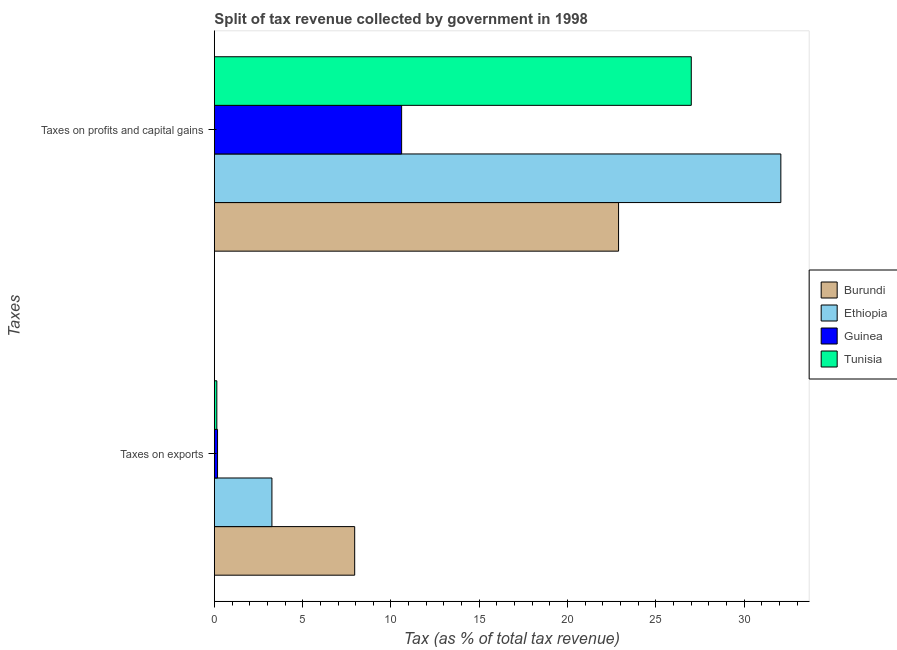How many different coloured bars are there?
Keep it short and to the point. 4. How many groups of bars are there?
Offer a very short reply. 2. Are the number of bars per tick equal to the number of legend labels?
Give a very brief answer. Yes. Are the number of bars on each tick of the Y-axis equal?
Make the answer very short. Yes. How many bars are there on the 2nd tick from the bottom?
Keep it short and to the point. 4. What is the label of the 1st group of bars from the top?
Provide a succinct answer. Taxes on profits and capital gains. What is the percentage of revenue obtained from taxes on exports in Guinea?
Provide a succinct answer. 0.18. Across all countries, what is the maximum percentage of revenue obtained from taxes on exports?
Make the answer very short. 7.94. Across all countries, what is the minimum percentage of revenue obtained from taxes on exports?
Keep it short and to the point. 0.14. In which country was the percentage of revenue obtained from taxes on profits and capital gains maximum?
Offer a terse response. Ethiopia. In which country was the percentage of revenue obtained from taxes on profits and capital gains minimum?
Ensure brevity in your answer.  Guinea. What is the total percentage of revenue obtained from taxes on profits and capital gains in the graph?
Offer a terse response. 92.55. What is the difference between the percentage of revenue obtained from taxes on profits and capital gains in Burundi and that in Ethiopia?
Give a very brief answer. -9.19. What is the difference between the percentage of revenue obtained from taxes on profits and capital gains in Ethiopia and the percentage of revenue obtained from taxes on exports in Guinea?
Your response must be concise. 31.89. What is the average percentage of revenue obtained from taxes on profits and capital gains per country?
Your answer should be compact. 23.14. What is the difference between the percentage of revenue obtained from taxes on profits and capital gains and percentage of revenue obtained from taxes on exports in Ethiopia?
Provide a short and direct response. 28.81. In how many countries, is the percentage of revenue obtained from taxes on profits and capital gains greater than 14 %?
Provide a succinct answer. 3. What is the ratio of the percentage of revenue obtained from taxes on exports in Ethiopia to that in Tunisia?
Offer a very short reply. 23.17. In how many countries, is the percentage of revenue obtained from taxes on profits and capital gains greater than the average percentage of revenue obtained from taxes on profits and capital gains taken over all countries?
Ensure brevity in your answer.  2. What does the 3rd bar from the top in Taxes on profits and capital gains represents?
Provide a succinct answer. Ethiopia. What does the 3rd bar from the bottom in Taxes on exports represents?
Your answer should be compact. Guinea. How many countries are there in the graph?
Your answer should be very brief. 4. Are the values on the major ticks of X-axis written in scientific E-notation?
Keep it short and to the point. No. Does the graph contain grids?
Your answer should be compact. No. How many legend labels are there?
Provide a succinct answer. 4. What is the title of the graph?
Keep it short and to the point. Split of tax revenue collected by government in 1998. What is the label or title of the X-axis?
Provide a succinct answer. Tax (as % of total tax revenue). What is the label or title of the Y-axis?
Provide a succinct answer. Taxes. What is the Tax (as % of total tax revenue) of Burundi in Taxes on exports?
Ensure brevity in your answer.  7.94. What is the Tax (as % of total tax revenue) of Ethiopia in Taxes on exports?
Ensure brevity in your answer.  3.26. What is the Tax (as % of total tax revenue) of Guinea in Taxes on exports?
Your answer should be very brief. 0.18. What is the Tax (as % of total tax revenue) in Tunisia in Taxes on exports?
Offer a very short reply. 0.14. What is the Tax (as % of total tax revenue) in Burundi in Taxes on profits and capital gains?
Keep it short and to the point. 22.88. What is the Tax (as % of total tax revenue) in Ethiopia in Taxes on profits and capital gains?
Provide a succinct answer. 32.07. What is the Tax (as % of total tax revenue) in Guinea in Taxes on profits and capital gains?
Keep it short and to the point. 10.6. What is the Tax (as % of total tax revenue) of Tunisia in Taxes on profits and capital gains?
Offer a terse response. 27. Across all Taxes, what is the maximum Tax (as % of total tax revenue) of Burundi?
Provide a succinct answer. 22.88. Across all Taxes, what is the maximum Tax (as % of total tax revenue) in Ethiopia?
Your response must be concise. 32.07. Across all Taxes, what is the maximum Tax (as % of total tax revenue) of Guinea?
Offer a terse response. 10.6. Across all Taxes, what is the maximum Tax (as % of total tax revenue) of Tunisia?
Give a very brief answer. 27. Across all Taxes, what is the minimum Tax (as % of total tax revenue) in Burundi?
Ensure brevity in your answer.  7.94. Across all Taxes, what is the minimum Tax (as % of total tax revenue) in Ethiopia?
Make the answer very short. 3.26. Across all Taxes, what is the minimum Tax (as % of total tax revenue) of Guinea?
Your response must be concise. 0.18. Across all Taxes, what is the minimum Tax (as % of total tax revenue) of Tunisia?
Ensure brevity in your answer.  0.14. What is the total Tax (as % of total tax revenue) in Burundi in the graph?
Give a very brief answer. 30.83. What is the total Tax (as % of total tax revenue) of Ethiopia in the graph?
Your answer should be very brief. 35.33. What is the total Tax (as % of total tax revenue) in Guinea in the graph?
Your answer should be compact. 10.78. What is the total Tax (as % of total tax revenue) in Tunisia in the graph?
Keep it short and to the point. 27.14. What is the difference between the Tax (as % of total tax revenue) of Burundi in Taxes on exports and that in Taxes on profits and capital gains?
Provide a succinct answer. -14.94. What is the difference between the Tax (as % of total tax revenue) in Ethiopia in Taxes on exports and that in Taxes on profits and capital gains?
Your answer should be compact. -28.81. What is the difference between the Tax (as % of total tax revenue) in Guinea in Taxes on exports and that in Taxes on profits and capital gains?
Offer a terse response. -10.42. What is the difference between the Tax (as % of total tax revenue) of Tunisia in Taxes on exports and that in Taxes on profits and capital gains?
Offer a terse response. -26.86. What is the difference between the Tax (as % of total tax revenue) of Burundi in Taxes on exports and the Tax (as % of total tax revenue) of Ethiopia in Taxes on profits and capital gains?
Keep it short and to the point. -24.12. What is the difference between the Tax (as % of total tax revenue) of Burundi in Taxes on exports and the Tax (as % of total tax revenue) of Guinea in Taxes on profits and capital gains?
Provide a short and direct response. -2.66. What is the difference between the Tax (as % of total tax revenue) in Burundi in Taxes on exports and the Tax (as % of total tax revenue) in Tunisia in Taxes on profits and capital gains?
Make the answer very short. -19.05. What is the difference between the Tax (as % of total tax revenue) of Ethiopia in Taxes on exports and the Tax (as % of total tax revenue) of Guinea in Taxes on profits and capital gains?
Your response must be concise. -7.34. What is the difference between the Tax (as % of total tax revenue) of Ethiopia in Taxes on exports and the Tax (as % of total tax revenue) of Tunisia in Taxes on profits and capital gains?
Give a very brief answer. -23.74. What is the difference between the Tax (as % of total tax revenue) in Guinea in Taxes on exports and the Tax (as % of total tax revenue) in Tunisia in Taxes on profits and capital gains?
Ensure brevity in your answer.  -26.82. What is the average Tax (as % of total tax revenue) in Burundi per Taxes?
Ensure brevity in your answer.  15.41. What is the average Tax (as % of total tax revenue) in Ethiopia per Taxes?
Make the answer very short. 17.66. What is the average Tax (as % of total tax revenue) of Guinea per Taxes?
Make the answer very short. 5.39. What is the average Tax (as % of total tax revenue) in Tunisia per Taxes?
Keep it short and to the point. 13.57. What is the difference between the Tax (as % of total tax revenue) in Burundi and Tax (as % of total tax revenue) in Ethiopia in Taxes on exports?
Offer a very short reply. 4.69. What is the difference between the Tax (as % of total tax revenue) in Burundi and Tax (as % of total tax revenue) in Guinea in Taxes on exports?
Keep it short and to the point. 7.76. What is the difference between the Tax (as % of total tax revenue) in Burundi and Tax (as % of total tax revenue) in Tunisia in Taxes on exports?
Offer a terse response. 7.8. What is the difference between the Tax (as % of total tax revenue) of Ethiopia and Tax (as % of total tax revenue) of Guinea in Taxes on exports?
Give a very brief answer. 3.08. What is the difference between the Tax (as % of total tax revenue) in Ethiopia and Tax (as % of total tax revenue) in Tunisia in Taxes on exports?
Make the answer very short. 3.12. What is the difference between the Tax (as % of total tax revenue) of Guinea and Tax (as % of total tax revenue) of Tunisia in Taxes on exports?
Your answer should be compact. 0.04. What is the difference between the Tax (as % of total tax revenue) in Burundi and Tax (as % of total tax revenue) in Ethiopia in Taxes on profits and capital gains?
Your answer should be compact. -9.19. What is the difference between the Tax (as % of total tax revenue) in Burundi and Tax (as % of total tax revenue) in Guinea in Taxes on profits and capital gains?
Provide a short and direct response. 12.28. What is the difference between the Tax (as % of total tax revenue) in Burundi and Tax (as % of total tax revenue) in Tunisia in Taxes on profits and capital gains?
Provide a succinct answer. -4.12. What is the difference between the Tax (as % of total tax revenue) in Ethiopia and Tax (as % of total tax revenue) in Guinea in Taxes on profits and capital gains?
Ensure brevity in your answer.  21.47. What is the difference between the Tax (as % of total tax revenue) in Ethiopia and Tax (as % of total tax revenue) in Tunisia in Taxes on profits and capital gains?
Your answer should be very brief. 5.07. What is the difference between the Tax (as % of total tax revenue) in Guinea and Tax (as % of total tax revenue) in Tunisia in Taxes on profits and capital gains?
Offer a very short reply. -16.4. What is the ratio of the Tax (as % of total tax revenue) of Burundi in Taxes on exports to that in Taxes on profits and capital gains?
Your response must be concise. 0.35. What is the ratio of the Tax (as % of total tax revenue) of Ethiopia in Taxes on exports to that in Taxes on profits and capital gains?
Keep it short and to the point. 0.1. What is the ratio of the Tax (as % of total tax revenue) of Guinea in Taxes on exports to that in Taxes on profits and capital gains?
Keep it short and to the point. 0.02. What is the ratio of the Tax (as % of total tax revenue) in Tunisia in Taxes on exports to that in Taxes on profits and capital gains?
Ensure brevity in your answer.  0.01. What is the difference between the highest and the second highest Tax (as % of total tax revenue) in Burundi?
Provide a succinct answer. 14.94. What is the difference between the highest and the second highest Tax (as % of total tax revenue) in Ethiopia?
Your response must be concise. 28.81. What is the difference between the highest and the second highest Tax (as % of total tax revenue) in Guinea?
Make the answer very short. 10.42. What is the difference between the highest and the second highest Tax (as % of total tax revenue) in Tunisia?
Give a very brief answer. 26.86. What is the difference between the highest and the lowest Tax (as % of total tax revenue) of Burundi?
Provide a succinct answer. 14.94. What is the difference between the highest and the lowest Tax (as % of total tax revenue) in Ethiopia?
Your response must be concise. 28.81. What is the difference between the highest and the lowest Tax (as % of total tax revenue) of Guinea?
Offer a terse response. 10.42. What is the difference between the highest and the lowest Tax (as % of total tax revenue) of Tunisia?
Provide a short and direct response. 26.86. 